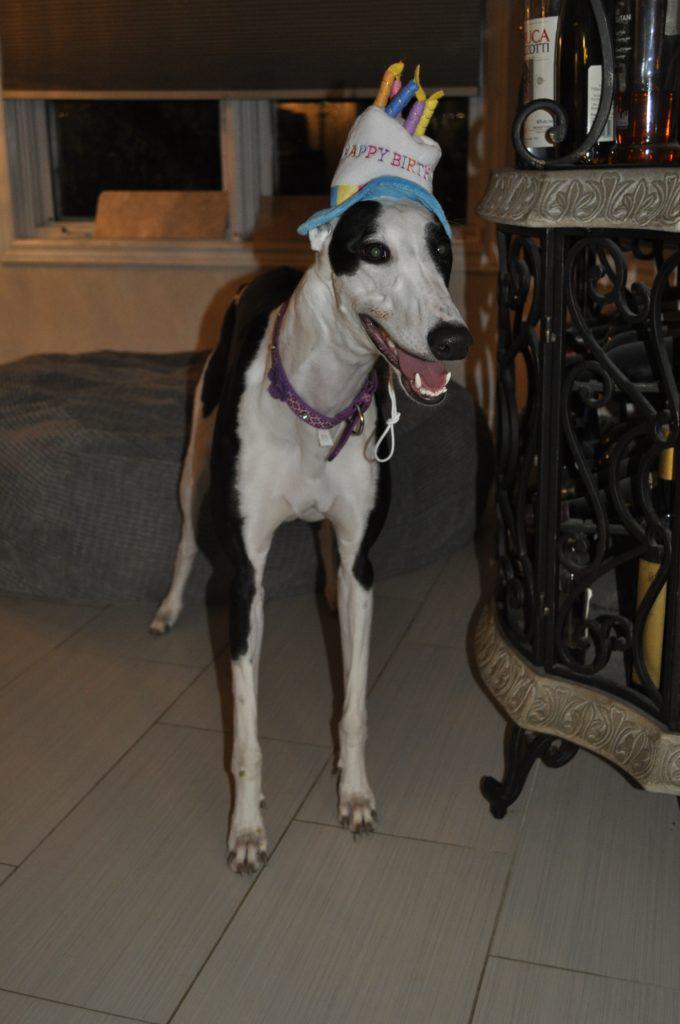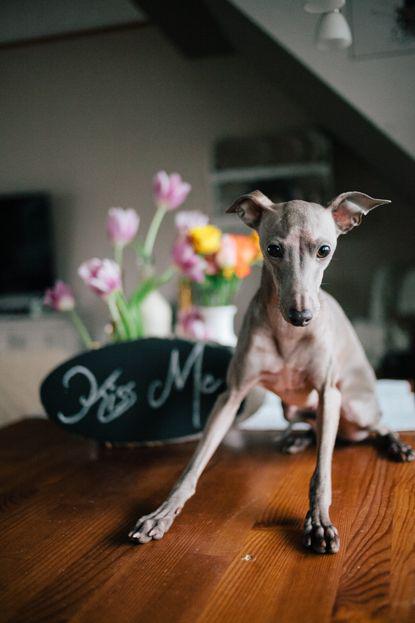The first image is the image on the left, the second image is the image on the right. Examine the images to the left and right. Is the description "At least one of the dogs has a hat on its head." accurate? Answer yes or no. Yes. The first image is the image on the left, the second image is the image on the right. Given the left and right images, does the statement "One image features a hound wearing a hat, and no image shows more than one hound figure." hold true? Answer yes or no. Yes. 